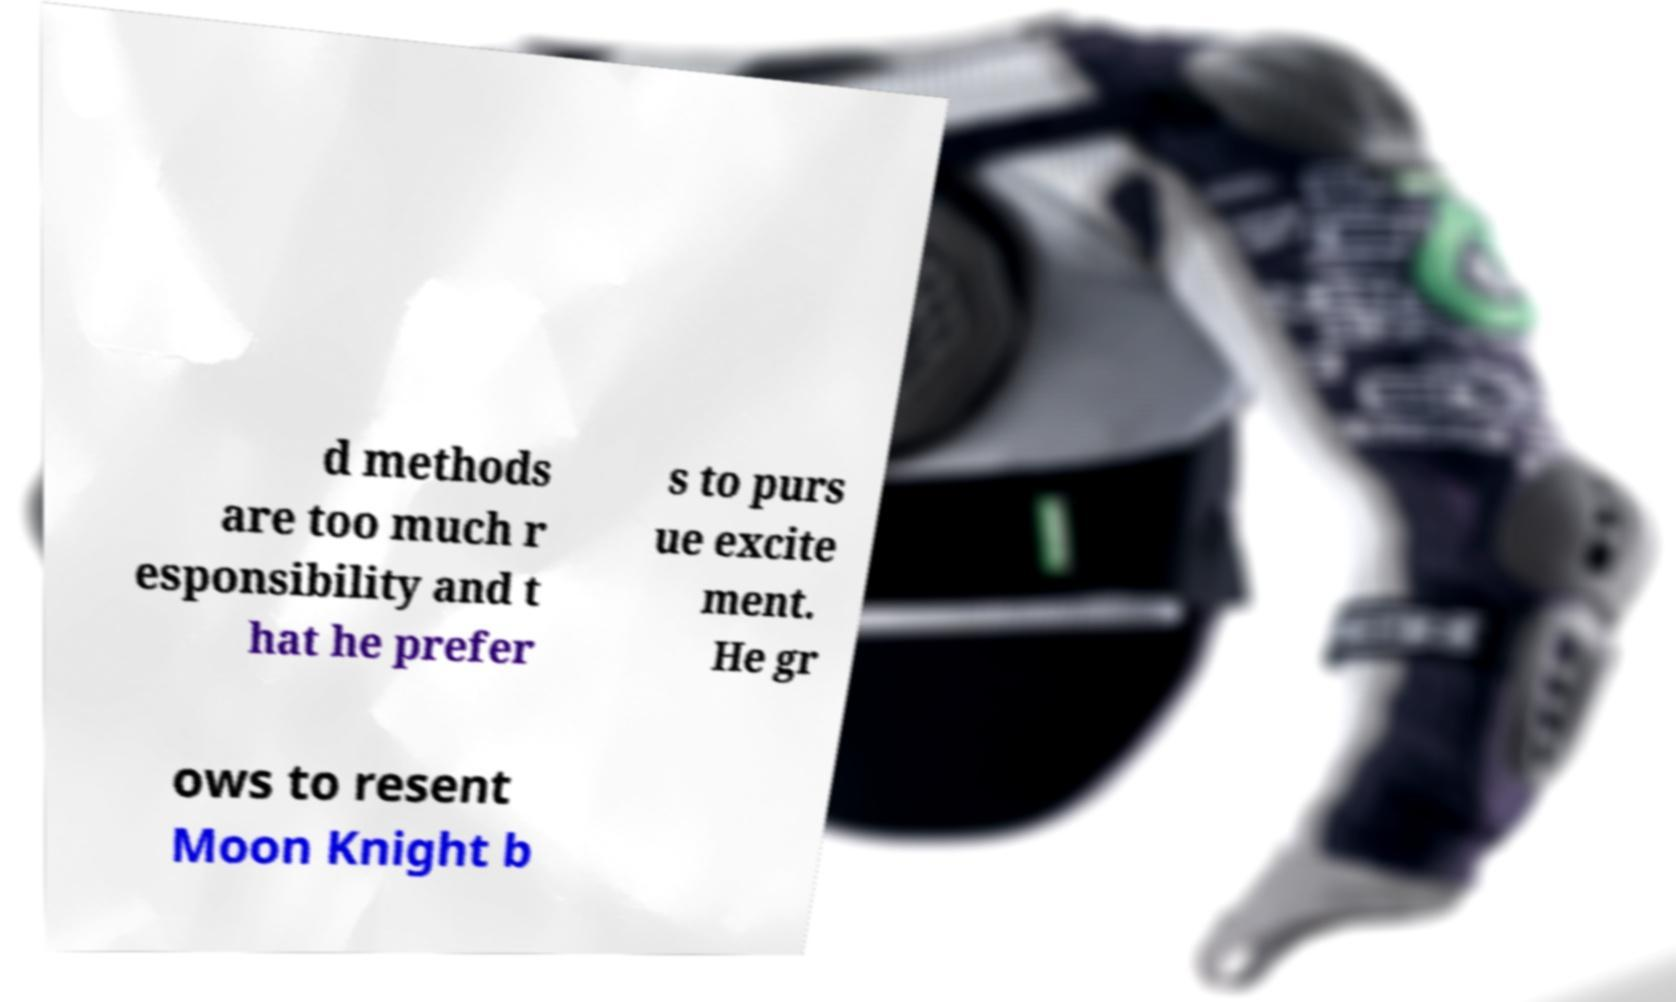Can you accurately transcribe the text from the provided image for me? d methods are too much r esponsibility and t hat he prefer s to purs ue excite ment. He gr ows to resent Moon Knight b 